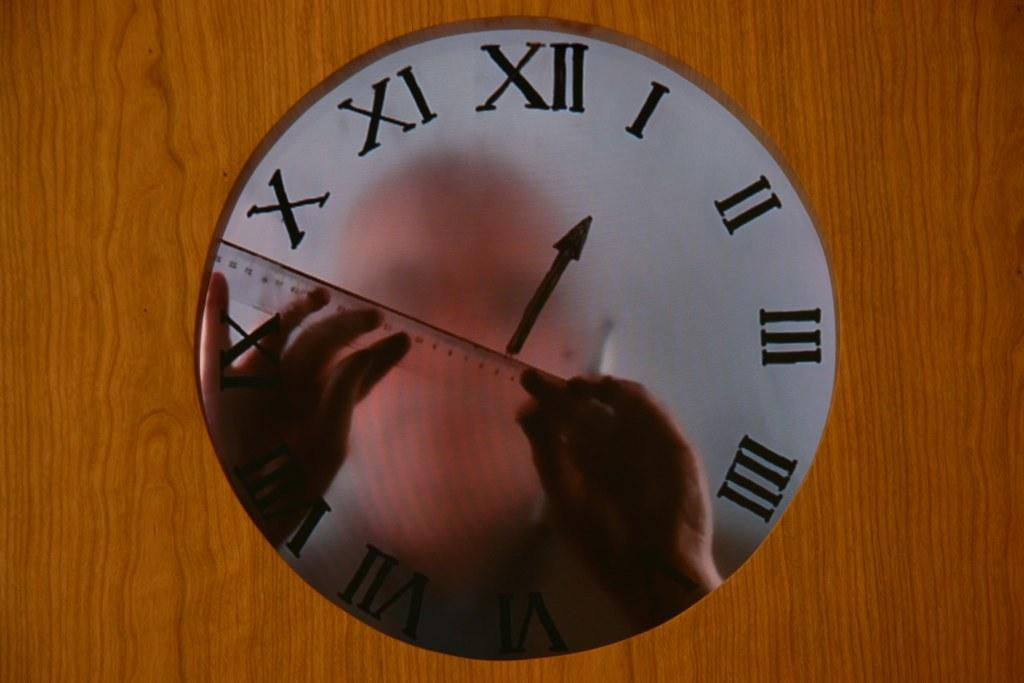Provide a one-sentence caption for the provided image. A man's reflection is displayed on a clock with the hand on I. 